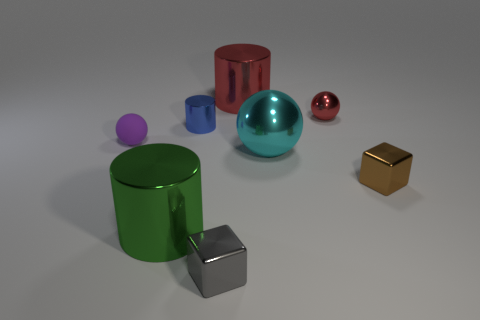What colors are represented by the objects? The objects display a variety of colors: red, green, blue, violet, gold, and silver. Could you associate these objects with anything from everyday life? Certainly, these objects resemble tabletop props that could be used in a still life painting or as part of a decorative arrangement, showcasing geometric shapes and vibrant colors. 